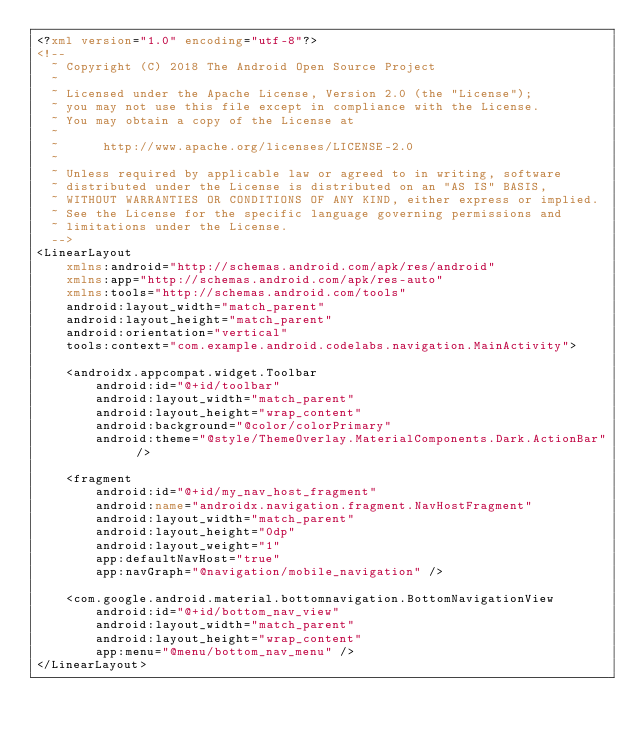<code> <loc_0><loc_0><loc_500><loc_500><_XML_><?xml version="1.0" encoding="utf-8"?>
<!--
  ~ Copyright (C) 2018 The Android Open Source Project
  ~
  ~ Licensed under the Apache License, Version 2.0 (the "License");
  ~ you may not use this file except in compliance with the License.
  ~ You may obtain a copy of the License at
  ~
  ~      http://www.apache.org/licenses/LICENSE-2.0
  ~
  ~ Unless required by applicable law or agreed to in writing, software
  ~ distributed under the License is distributed on an "AS IS" BASIS,
  ~ WITHOUT WARRANTIES OR CONDITIONS OF ANY KIND, either express or implied.
  ~ See the License for the specific language governing permissions and
  ~ limitations under the License.
  -->
<LinearLayout
    xmlns:android="http://schemas.android.com/apk/res/android"
    xmlns:app="http://schemas.android.com/apk/res-auto"
    xmlns:tools="http://schemas.android.com/tools"
    android:layout_width="match_parent"
    android:layout_height="match_parent"
    android:orientation="vertical"
    tools:context="com.example.android.codelabs.navigation.MainActivity">

    <androidx.appcompat.widget.Toolbar
        android:id="@+id/toolbar"
        android:layout_width="match_parent"
        android:layout_height="wrap_content"
        android:background="@color/colorPrimary"
        android:theme="@style/ThemeOverlay.MaterialComponents.Dark.ActionBar" />

    <fragment
        android:id="@+id/my_nav_host_fragment"
        android:name="androidx.navigation.fragment.NavHostFragment"
        android:layout_width="match_parent"
        android:layout_height="0dp"
        android:layout_weight="1"
        app:defaultNavHost="true"
        app:navGraph="@navigation/mobile_navigation" />

    <com.google.android.material.bottomnavigation.BottomNavigationView
        android:id="@+id/bottom_nav_view"
        android:layout_width="match_parent"
        android:layout_height="wrap_content"
        app:menu="@menu/bottom_nav_menu" />
</LinearLayout>
</code> 